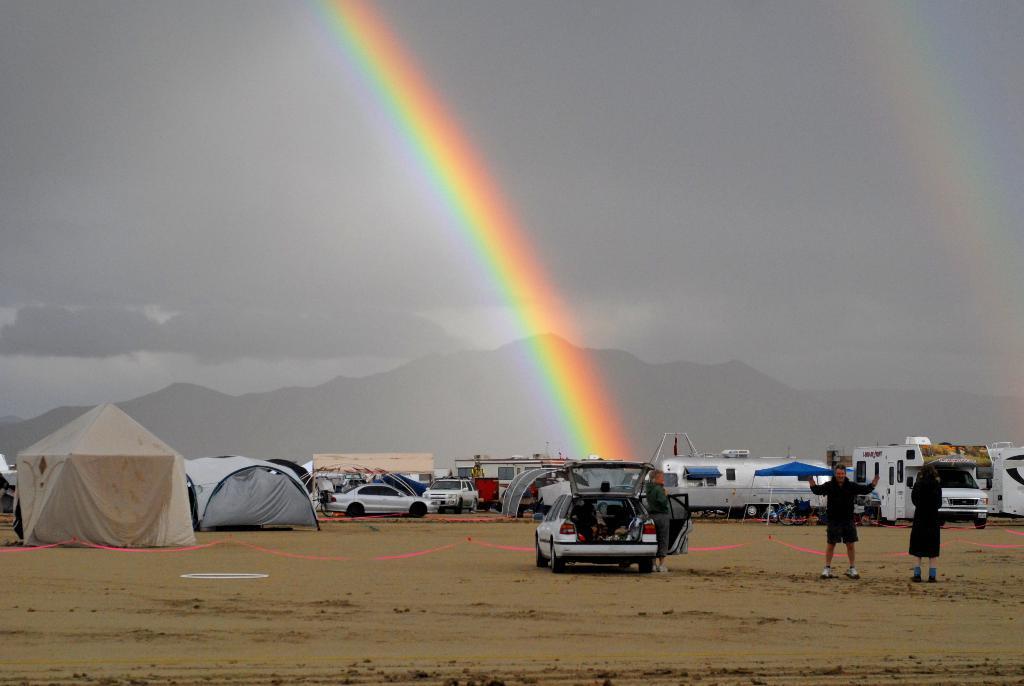Please provide a concise description of this image. On the right side of the image we can see two persons are standing. In the center of the image, we can see a few vehicles, tents and a few other objects. In the background, we can see the sky, hills and a rainbow. 